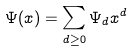Convert formula to latex. <formula><loc_0><loc_0><loc_500><loc_500>\Psi ( x ) = \sum _ { d \geq 0 } \Psi _ { d } x ^ { d }</formula> 